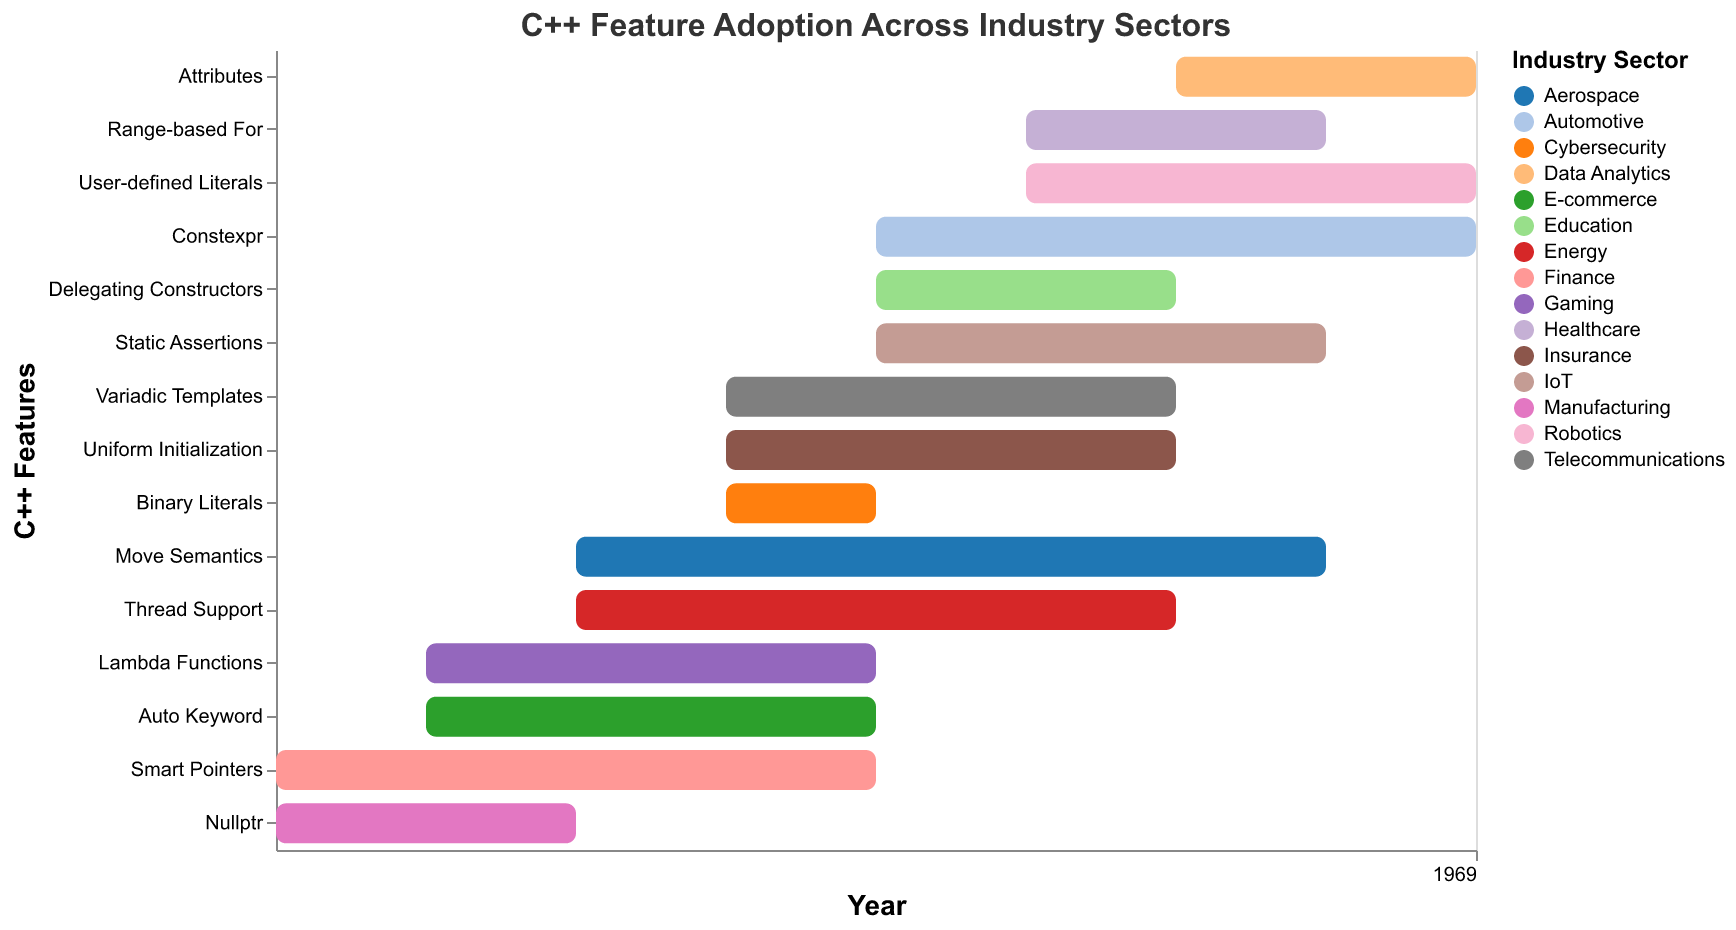What is the duration of Smart Pointers adoption in the Finance sector? By looking at the bar chart, Smart Pointers in the Finance sector start in 2011 and their duration is 4 years, which is directly indicated by the bar length.
Answer: 4 years Which feature has the longest adoption duration and in which sector? Amongst all features, Move Semantics in the Aerospace sector has the longest duration as per the end year and start year data. Start year is 2013 and duration is 5 years (ends in 2018).
Answer: Move Semantics, Aerospace Which industry sectors adopted features starting in 2012? The industry sectors with features starting from 2012 in the chart are Gaming (Lambda Functions) and E-commerce (Auto Keyword).
Answer: Gaming, E-commerce Which feature saw adoption in the Automotive sector, and what was its start and duration? By examining the chart, the feature adopted in the Automotive sector is Constexpr, which started in 2015 and had a duration of 4 years.
Answer: Constexpr, 2015, 4 years Compare the adoption period of Thread Support in Energy sector and Uniform Initialization in Insurance sector. Which one was earlier and by how many years? Thread Support started in 2013 and lasted 4 years, ending in 2017. Uniform Initialization started in 2014 and lasted 3 years, ending in 2017 as well. Thus, Thread Support started one year earlier.
Answer: Thread Support, by 1 year Which C++ feature was adopted in the Healthcare sector and what were its start and end years? The feature in the Healthcare sector is Range-based For, which started in 2016 and lasted 2 years, thus it ended in 2018 (2016+2=2018).
Answer: Range-based For, 2016-2018 What was the shortest adoption duration for a feature, and in which sector was it? By observing the chart, the shortest duration is 1 year for the Binary Literals feature in the Cybersecurity sector, starting in 2014 and ending in 2015.
Answer: Binary Literals, Cybersecurity How many features were adopted across all sectors in the year 2015? Looking at the start years, four features began adoption in 2015: Constexpr in Automotive, Delegating Constructors in Education, Static Assertions in IoT, and Smart Pointers in Finance.
Answer: 4 features If the average duration of adoption across all features is calculated, which sectors have an above-average adoption duration? The total duration for all features sums to (4 + 3 + 5 + 3 + 4 + 2 + 3 + 2 + 4 + 3 + 2 + 3 + 2 + 1 + 3) = 40 years over 15 features, averaging to 40/15 ≈ 2.67 years. Features with durations above 2.67 years are: Smart Pointers (Finance), Move Semantics (Aerospace), Constexpr (Automotive), Auto Keyword (E-commerce), Thread Support (Energy), Variadic Templates (Telecommunications), and Static Assertions (IoT).
Answer: Finance, Aerospace, Automotive, E-commerce, Energy, Telecommunications, IoT 